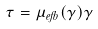<formula> <loc_0><loc_0><loc_500><loc_500>\tau = \mu _ { e f f } ( \dot { \gamma } ) \dot { \gamma }</formula> 